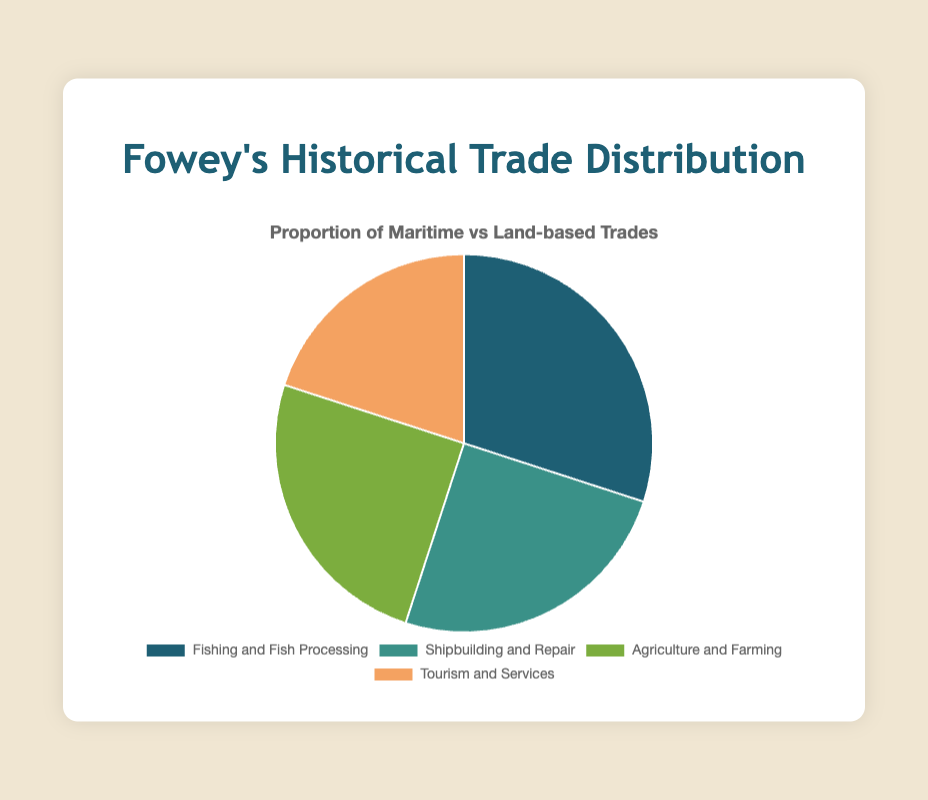Which trade has the highest proportion? The trade "Fishing and Fish Processing" is the largest segment in the pie chart, as it occupies the most significant area.
Answer: Fishing and Fish Processing What is the combined proportion of maritime trades? Sum the proportions of "Fishing and Fish Processing" and "Shipbuilding and Repair" (30% + 25%) to get the total proportion of maritime trades.
Answer: 55% Which land-based trade has a smaller proportion than "Shipbuilding and Repair"? Both "Agriculture and Farming" and "Tourism and Services" are part of land-based trades. Comparing their values, "Tourism and Services" has a smaller proportion (20%) than "Shipbuilding and Repair" (25%).
Answer: Tourism and Services How do the proportions of "Fishing and Fish Processing" and "Agriculture and Farming" compare? The proportion of "Fishing and Fish Processing" is 30%, while "Agriculture and Farming" is 25%. 30% is greater than 25%, so "Fishing and Fish Processing" has a higher proportion.
Answer: Fishing and Fish Processing has a higher proportion What is the average proportion of all trades in this chart? Sum the proportions of all trades (30 + 25 + 25 + 20 = 100) and divide by the number of trades (4). The average proportion is 100 / 4 = 25%.
Answer: 25% Which segment is represented by the green color? By examining the chart, the green color is associated with the segment "Shipbuilding and Repair".
Answer: Shipbuilding and Repair What is the difference in proportion between "Fishing and Fish Processing" and "Tourism and Services"? Subtract the proportion of "Tourism and Services" (20%) from the proportion of "Fishing and Fish Processing" (30%): 30% - 20% = 10%.
Answer: 10% Are the proportions of "Agriculture and Farming" and "Shipbuilding and Repair" equal? Both "Agriculture and Farming" and "Shipbuilding and Repair" have a proportion of 25%, which means they are equal.
Answer: Yes What is the least represented trade in the chart? The pie chart shows that "Tourism and Services" has the smallest segment with a proportion of 20%.
Answer: Tourism and Services 